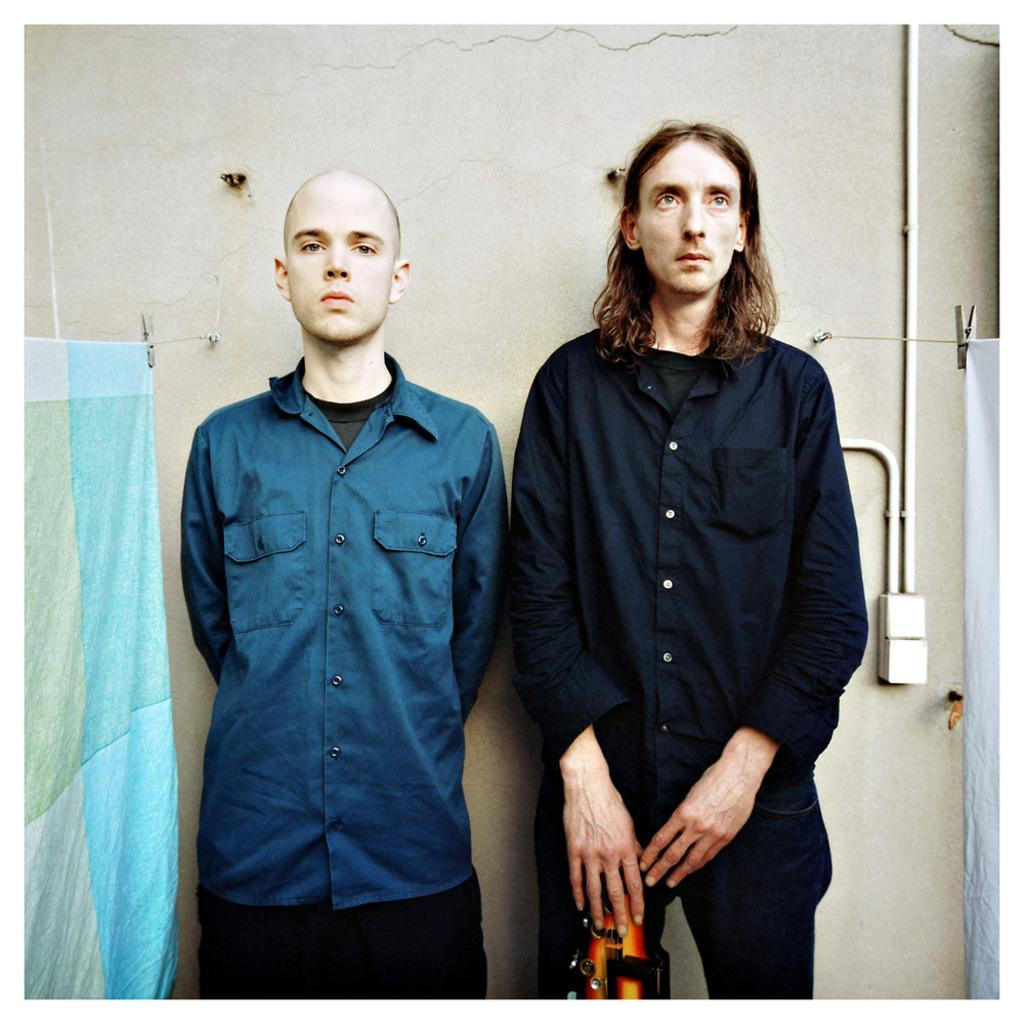How many people are in the image? There are two men standing in the image. What might the blankets be used for in the image? The blankets are present beside the men, possibly for warmth or comfort. What type of clover can be seen growing near the men in the image? There is no clover present in the image; it only features two men and blankets. 